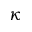Convert formula to latex. <formula><loc_0><loc_0><loc_500><loc_500>\kappa</formula> 